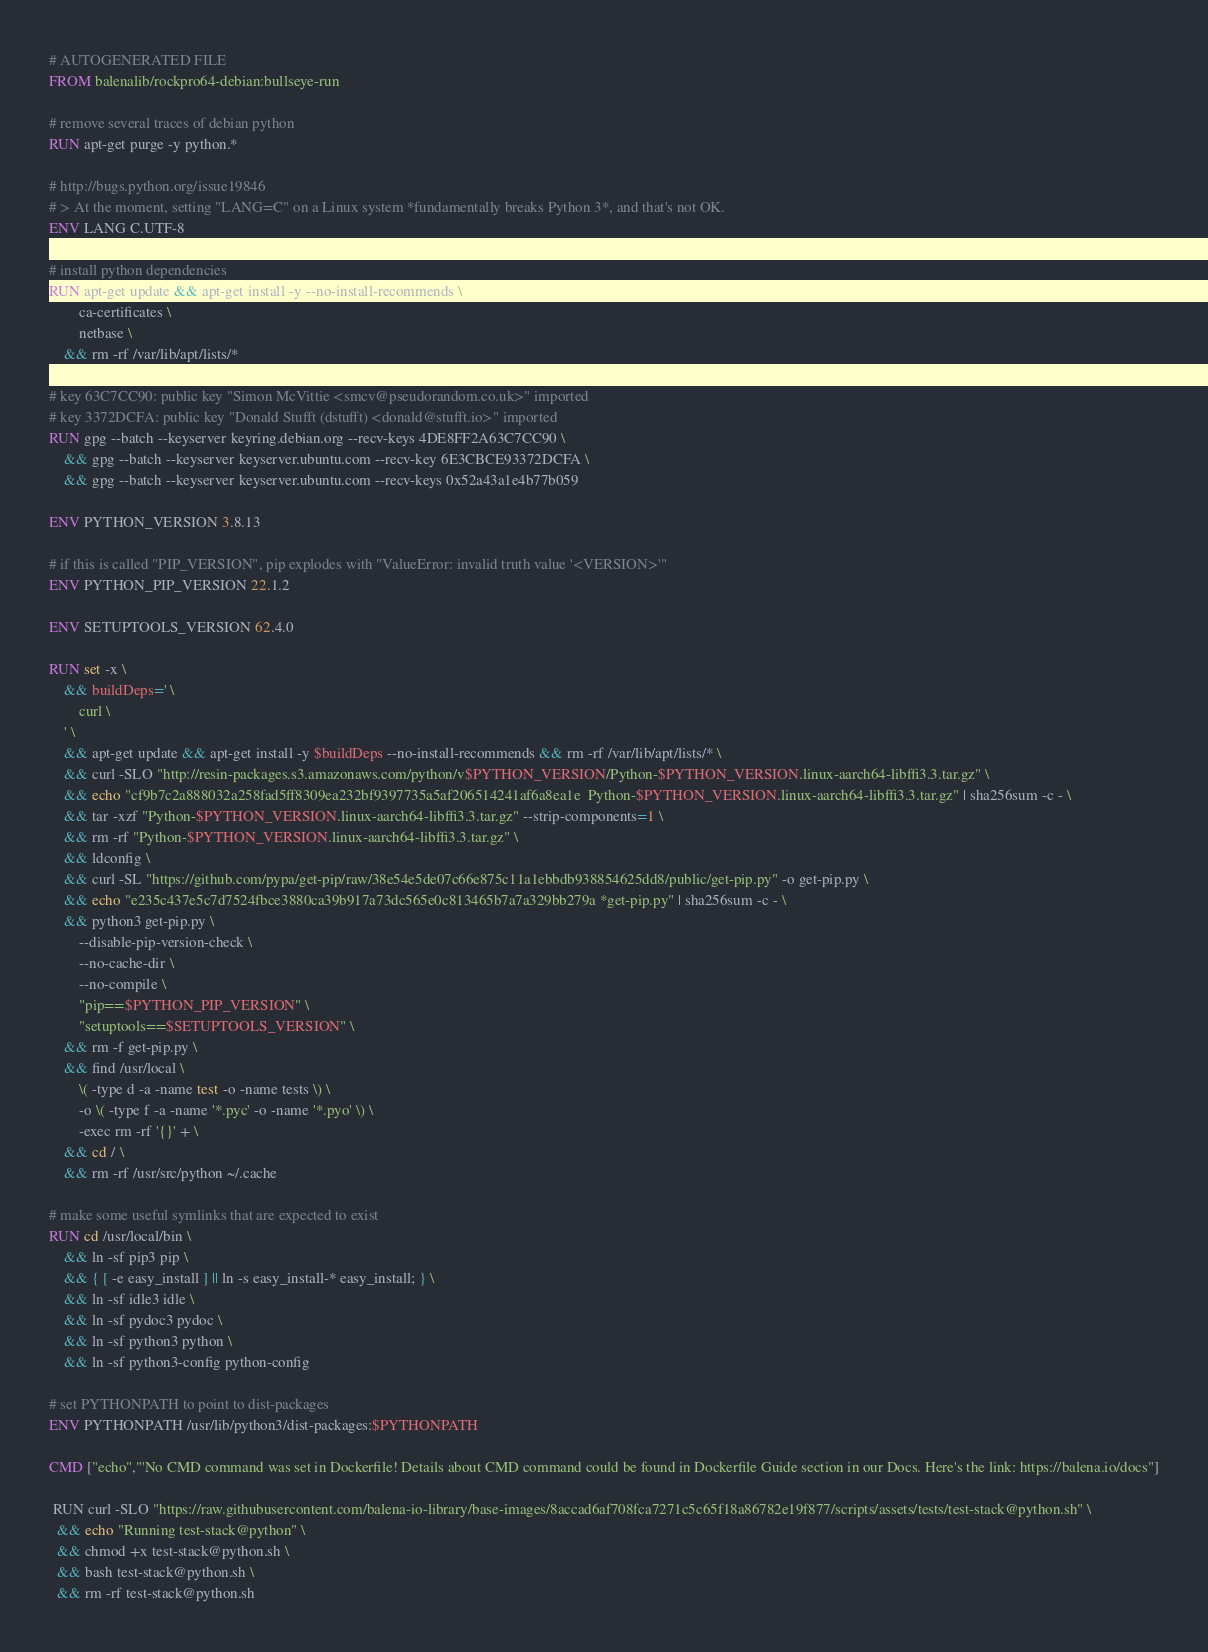Convert code to text. <code><loc_0><loc_0><loc_500><loc_500><_Dockerfile_># AUTOGENERATED FILE
FROM balenalib/rockpro64-debian:bullseye-run

# remove several traces of debian python
RUN apt-get purge -y python.*

# http://bugs.python.org/issue19846
# > At the moment, setting "LANG=C" on a Linux system *fundamentally breaks Python 3*, and that's not OK.
ENV LANG C.UTF-8

# install python dependencies
RUN apt-get update && apt-get install -y --no-install-recommends \
		ca-certificates \
		netbase \
	&& rm -rf /var/lib/apt/lists/*

# key 63C7CC90: public key "Simon McVittie <smcv@pseudorandom.co.uk>" imported
# key 3372DCFA: public key "Donald Stufft (dstufft) <donald@stufft.io>" imported
RUN gpg --batch --keyserver keyring.debian.org --recv-keys 4DE8FF2A63C7CC90 \
	&& gpg --batch --keyserver keyserver.ubuntu.com --recv-key 6E3CBCE93372DCFA \
	&& gpg --batch --keyserver keyserver.ubuntu.com --recv-keys 0x52a43a1e4b77b059

ENV PYTHON_VERSION 3.8.13

# if this is called "PIP_VERSION", pip explodes with "ValueError: invalid truth value '<VERSION>'"
ENV PYTHON_PIP_VERSION 22.1.2

ENV SETUPTOOLS_VERSION 62.4.0

RUN set -x \
	&& buildDeps=' \
		curl \
	' \
	&& apt-get update && apt-get install -y $buildDeps --no-install-recommends && rm -rf /var/lib/apt/lists/* \
	&& curl -SLO "http://resin-packages.s3.amazonaws.com/python/v$PYTHON_VERSION/Python-$PYTHON_VERSION.linux-aarch64-libffi3.3.tar.gz" \
	&& echo "cf9b7c2a888032a258fad5ff8309ea232bf9397735a5af206514241af6a8ea1e  Python-$PYTHON_VERSION.linux-aarch64-libffi3.3.tar.gz" | sha256sum -c - \
	&& tar -xzf "Python-$PYTHON_VERSION.linux-aarch64-libffi3.3.tar.gz" --strip-components=1 \
	&& rm -rf "Python-$PYTHON_VERSION.linux-aarch64-libffi3.3.tar.gz" \
	&& ldconfig \
	&& curl -SL "https://github.com/pypa/get-pip/raw/38e54e5de07c66e875c11a1ebbdb938854625dd8/public/get-pip.py" -o get-pip.py \
    && echo "e235c437e5c7d7524fbce3880ca39b917a73dc565e0c813465b7a7a329bb279a *get-pip.py" | sha256sum -c - \
    && python3 get-pip.py \
        --disable-pip-version-check \
        --no-cache-dir \
        --no-compile \
        "pip==$PYTHON_PIP_VERSION" \
        "setuptools==$SETUPTOOLS_VERSION" \
	&& rm -f get-pip.py \
	&& find /usr/local \
		\( -type d -a -name test -o -name tests \) \
		-o \( -type f -a -name '*.pyc' -o -name '*.pyo' \) \
		-exec rm -rf '{}' + \
	&& cd / \
	&& rm -rf /usr/src/python ~/.cache

# make some useful symlinks that are expected to exist
RUN cd /usr/local/bin \
	&& ln -sf pip3 pip \
	&& { [ -e easy_install ] || ln -s easy_install-* easy_install; } \
	&& ln -sf idle3 idle \
	&& ln -sf pydoc3 pydoc \
	&& ln -sf python3 python \
	&& ln -sf python3-config python-config

# set PYTHONPATH to point to dist-packages
ENV PYTHONPATH /usr/lib/python3/dist-packages:$PYTHONPATH

CMD ["echo","'No CMD command was set in Dockerfile! Details about CMD command could be found in Dockerfile Guide section in our Docs. Here's the link: https://balena.io/docs"]

 RUN curl -SLO "https://raw.githubusercontent.com/balena-io-library/base-images/8accad6af708fca7271c5c65f18a86782e19f877/scripts/assets/tests/test-stack@python.sh" \
  && echo "Running test-stack@python" \
  && chmod +x test-stack@python.sh \
  && bash test-stack@python.sh \
  && rm -rf test-stack@python.sh 
</code> 